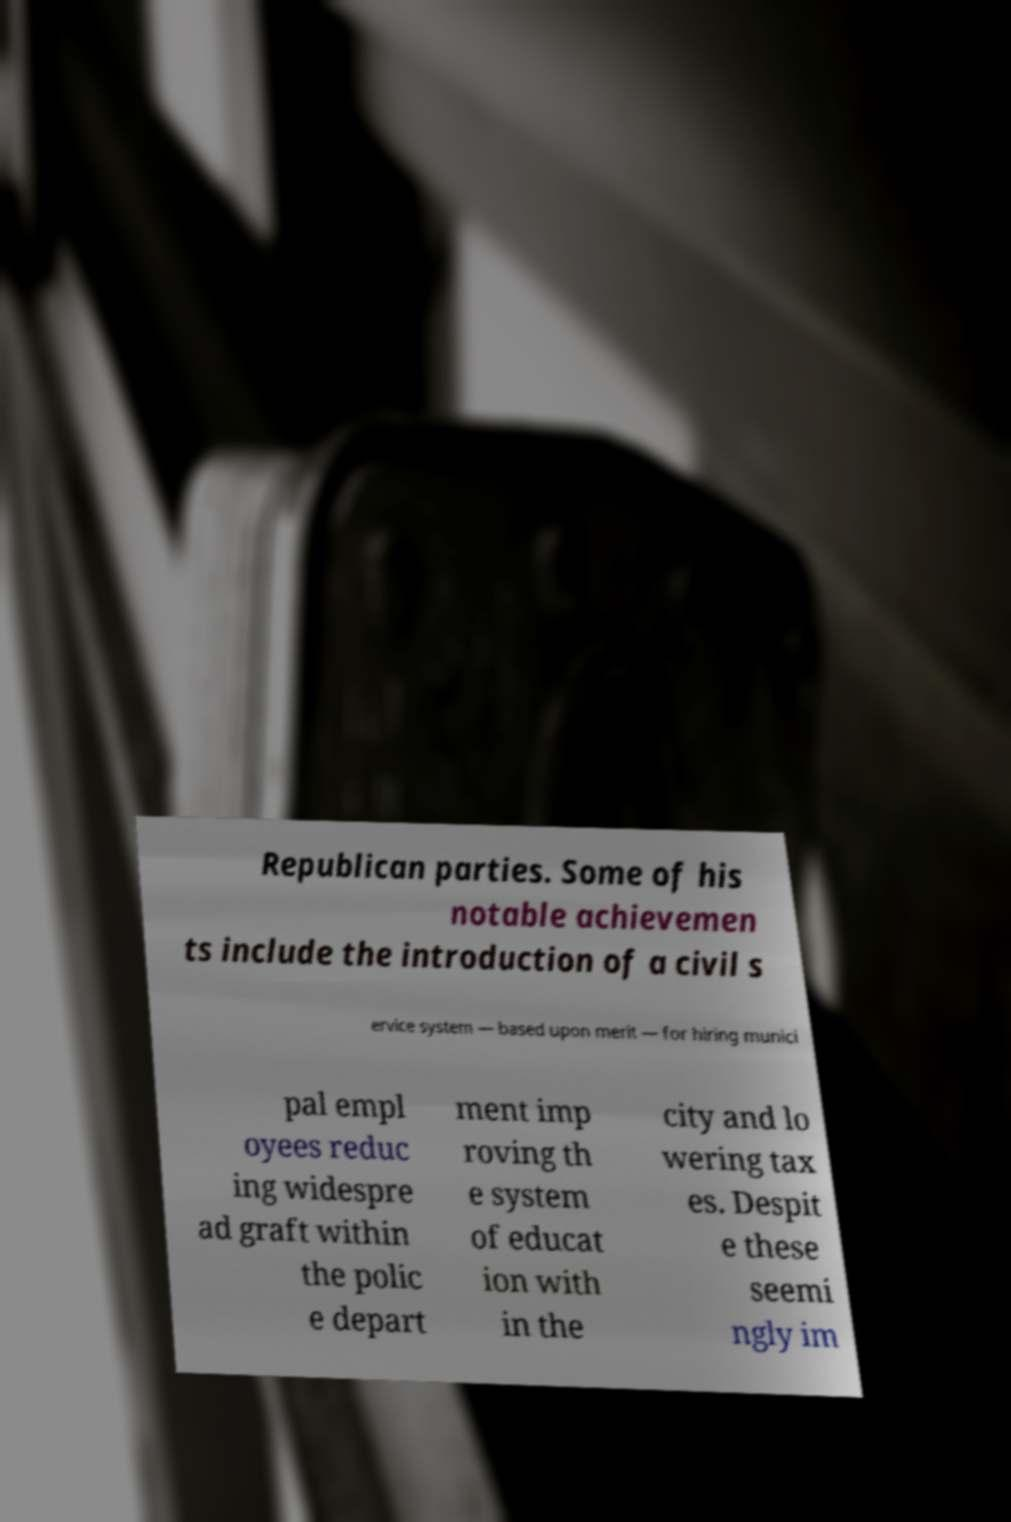Could you assist in decoding the text presented in this image and type it out clearly? Republican parties. Some of his notable achievemen ts include the introduction of a civil s ervice system — based upon merit — for hiring munici pal empl oyees reduc ing widespre ad graft within the polic e depart ment imp roving th e system of educat ion with in the city and lo wering tax es. Despit e these seemi ngly im 